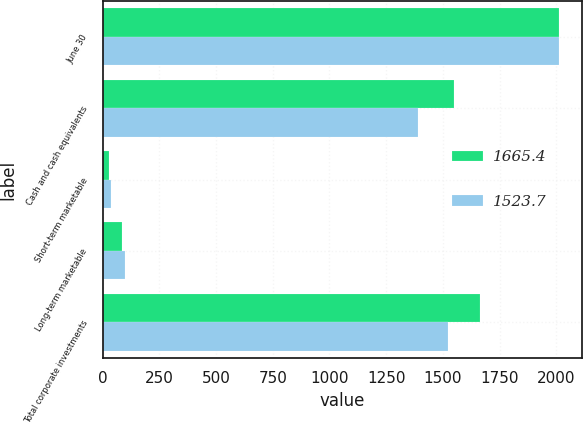Convert chart. <chart><loc_0><loc_0><loc_500><loc_500><stacked_bar_chart><ecel><fcel>June 30<fcel>Cash and cash equivalents<fcel>Short-term marketable<fcel>Long-term marketable<fcel>Total corporate investments<nl><fcel>1665.4<fcel>2012<fcel>1548.1<fcel>30.4<fcel>86.9<fcel>1665.4<nl><fcel>1523.7<fcel>2011<fcel>1389.4<fcel>36.3<fcel>98<fcel>1523.7<nl></chart> 